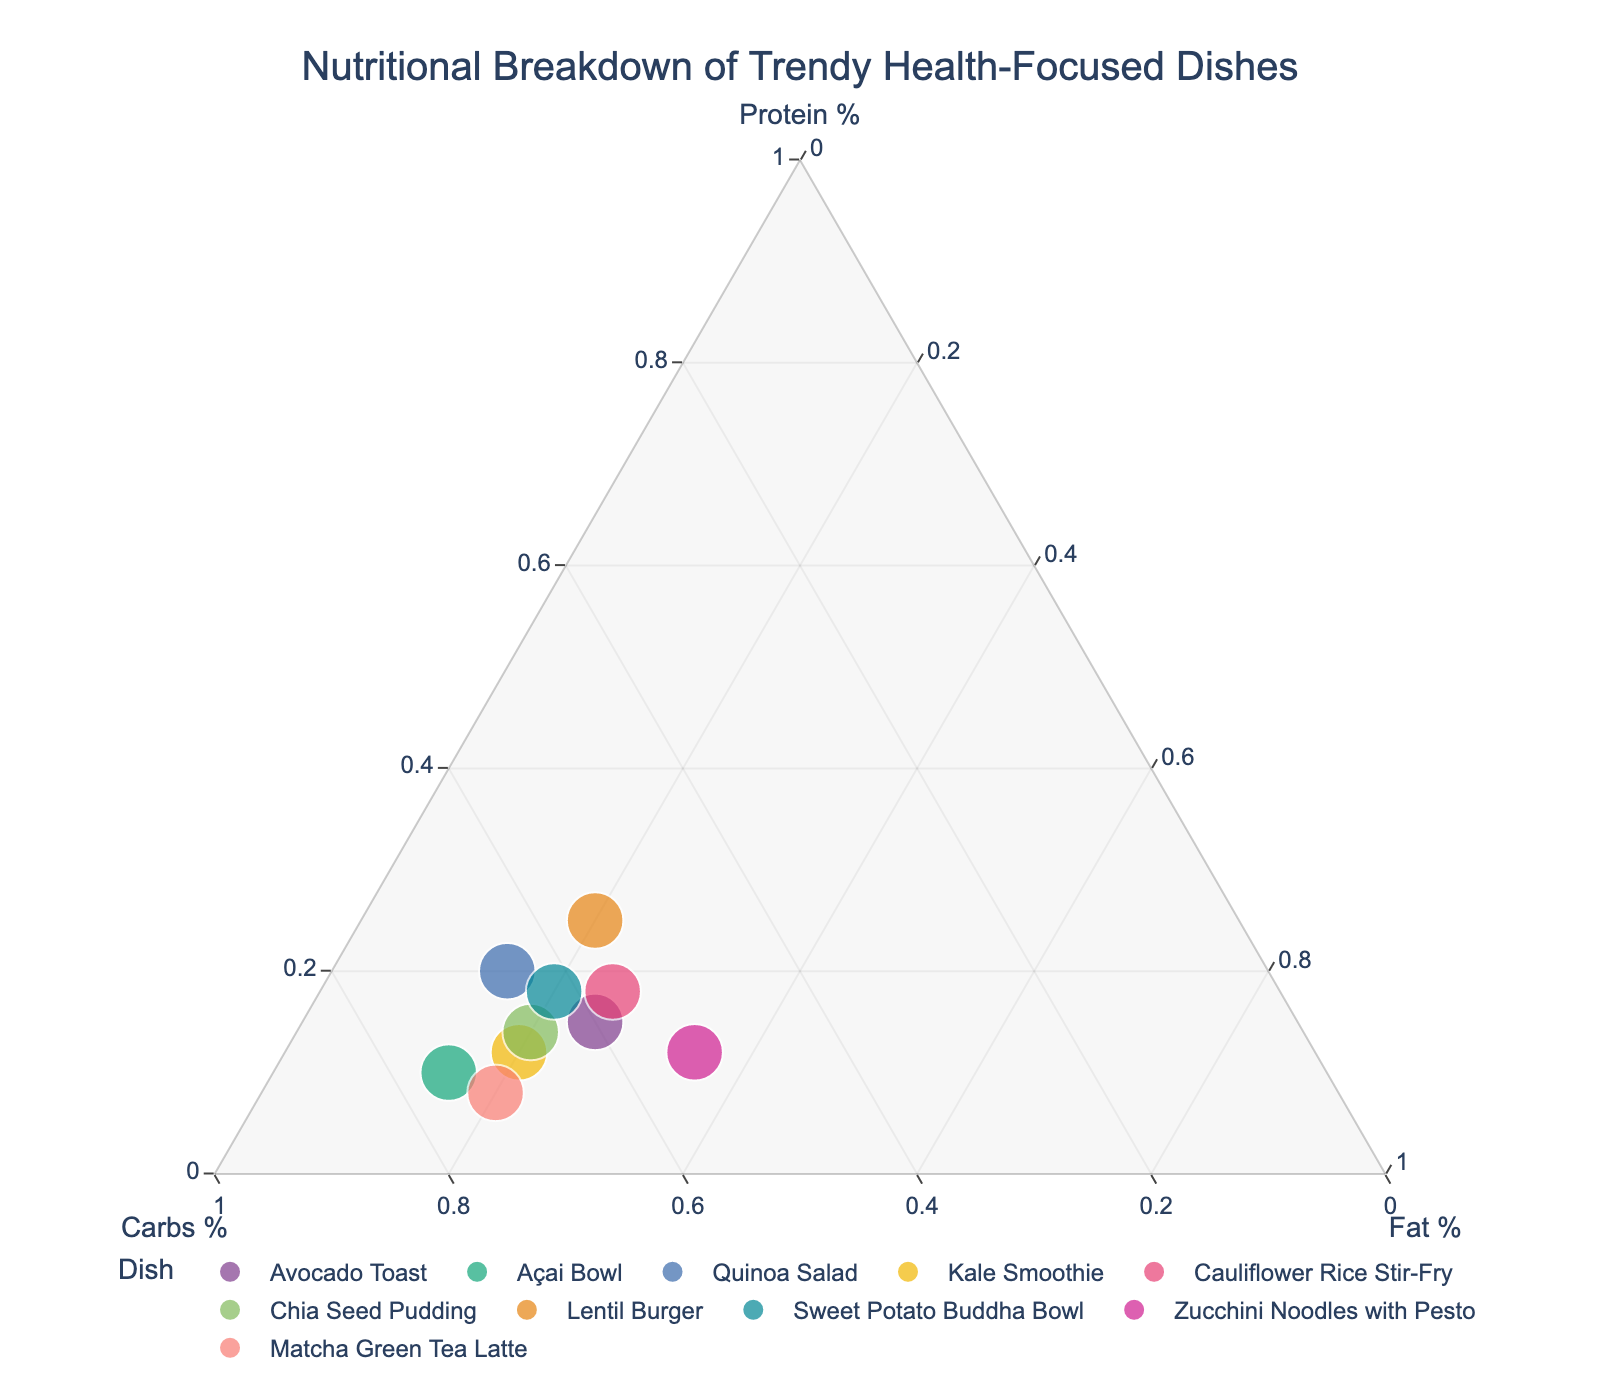How many dishes are represented in the plot? Count the number of unique data points (dishes) in the figure.
Answer: 10 What's the highest percentage of carbs found in any dish? Look for the dish with the highest position along the 'Carbs %' axis. The Açai Bowl shows the highest proportion of carbs, which is 75%.
Answer: 75% What are the approximate protein, carbs, and fat percentages of the Avocado Toast? Locate the Avocado Toast data point and read the three axis percentages: approximately 15% protein, 60% carbs, and 25% fat.
Answer: 15% protein, 60% carbs, 25% fat Which dish is the closest to having equal percentages of protein, carbs, and fat? Find the dish near the center of the triangle where all three percentages are about equal. The Lentil Burger is closest, with 25% protein, 55% carbs, and 20% fat.
Answer: Lentil Burger Which dish has the highest percentage of fat? Look for the point closest to the 'Fat %' axis's maximum. Zucchini Noodles with Pesto have the highest fat percentage at 35%.
Answer: Zucchini Noodles with Pesto Is there any dish with a higher protein percentage than carbs percentage? Compare protein and carbs percentages for each dish. The Lentil Burger has a higher protein (25%) than carbs (55%) percentage.
Answer: No Which dish has a weightier position towards proteins in comparison to Kale Smoothie? Compare the protein percentages of Kale Smoothie with other dishes. Zucchini Noodles with Pesto and Lentil Burger both have a higher protein percentage than Kale Smoothie.
Answer: Zucchini Noodles with Pesto, Lentil Burger Calculate the combined protein, carbs, and fat percentages of Quinoa Salad and Chia Seed Pudding. Add the percentages of protein, carbs, and fat for both dishes individually: (20+65+15) + (14+66+20) = (100) + (100) = 200%.
Answer: 200% Which dish shows a similar nutritional breakdown to Cauliflower Rice Stir-Fry based on their position? Compare the positional proximity of dishes to Cauliflower Rice Stir-Fry. Sweet Potato Buddha Bowl is close regarding their nutritional breakdown.
Answer: Sweet Potato Buddha Bowl In terms of nutritional composition, what stands out more, the protein or carb percentage in Matcha Green Tea Latte? Assess the relative position and percentage values for protein and carbs for Matcha Green Tea Latte, which are 8% and 72% respectively.
Answer: Carb percentage 